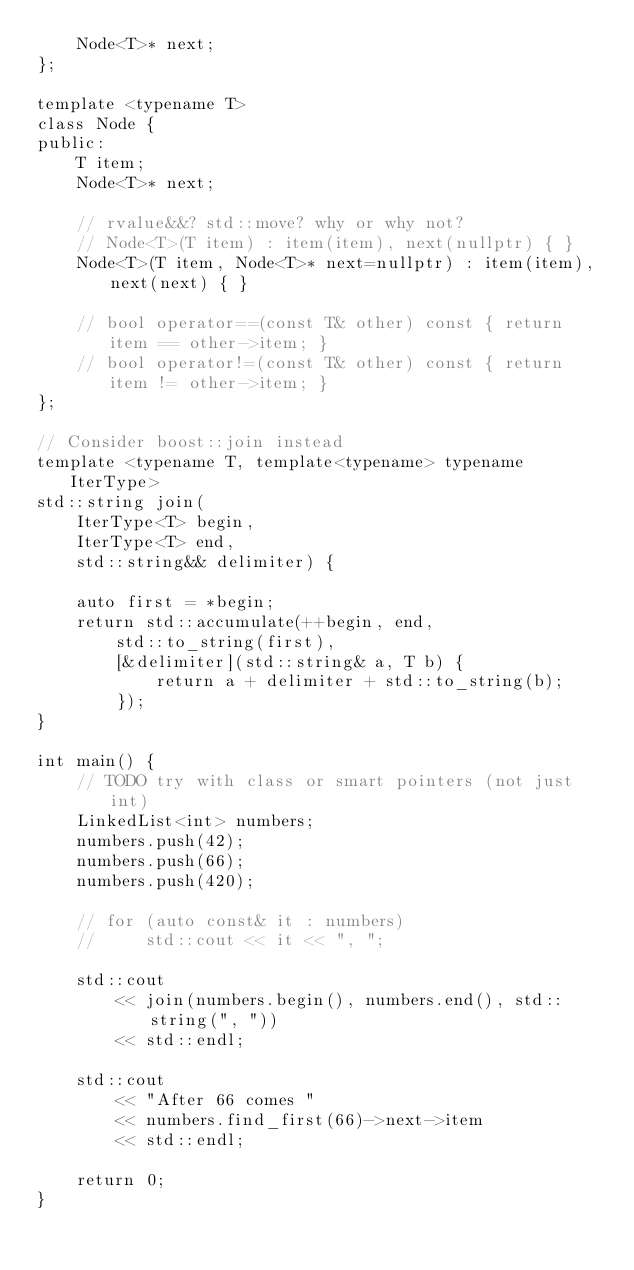<code> <loc_0><loc_0><loc_500><loc_500><_C++_>    Node<T>* next;
};

template <typename T>
class Node {
public:
    T item;
    Node<T>* next;

    // rvalue&&? std::move? why or why not?
    // Node<T>(T item) : item(item), next(nullptr) { }
    Node<T>(T item, Node<T>* next=nullptr) : item(item), next(next) { }

    // bool operator==(const T& other) const { return item == other->item; }
    // bool operator!=(const T& other) const { return item != other->item; }
};

// Consider boost::join instead
template <typename T, template<typename> typename IterType>
std::string join(
    IterType<T> begin,
    IterType<T> end,
    std::string&& delimiter) {

    auto first = *begin;
    return std::accumulate(++begin, end,
        std::to_string(first),
        [&delimiter](std::string& a, T b) {
            return a + delimiter + std::to_string(b);
        });
}

int main() {
    // TODO try with class or smart pointers (not just int)
    LinkedList<int> numbers;
    numbers.push(42);
    numbers.push(66);
    numbers.push(420);

    // for (auto const& it : numbers)
    //     std::cout << it << ", ";

    std::cout
        << join(numbers.begin(), numbers.end(), std::string(", "))
        << std::endl;

    std::cout
        << "After 66 comes "
        << numbers.find_first(66)->next->item
        << std::endl;

    return 0;
}

</code> 